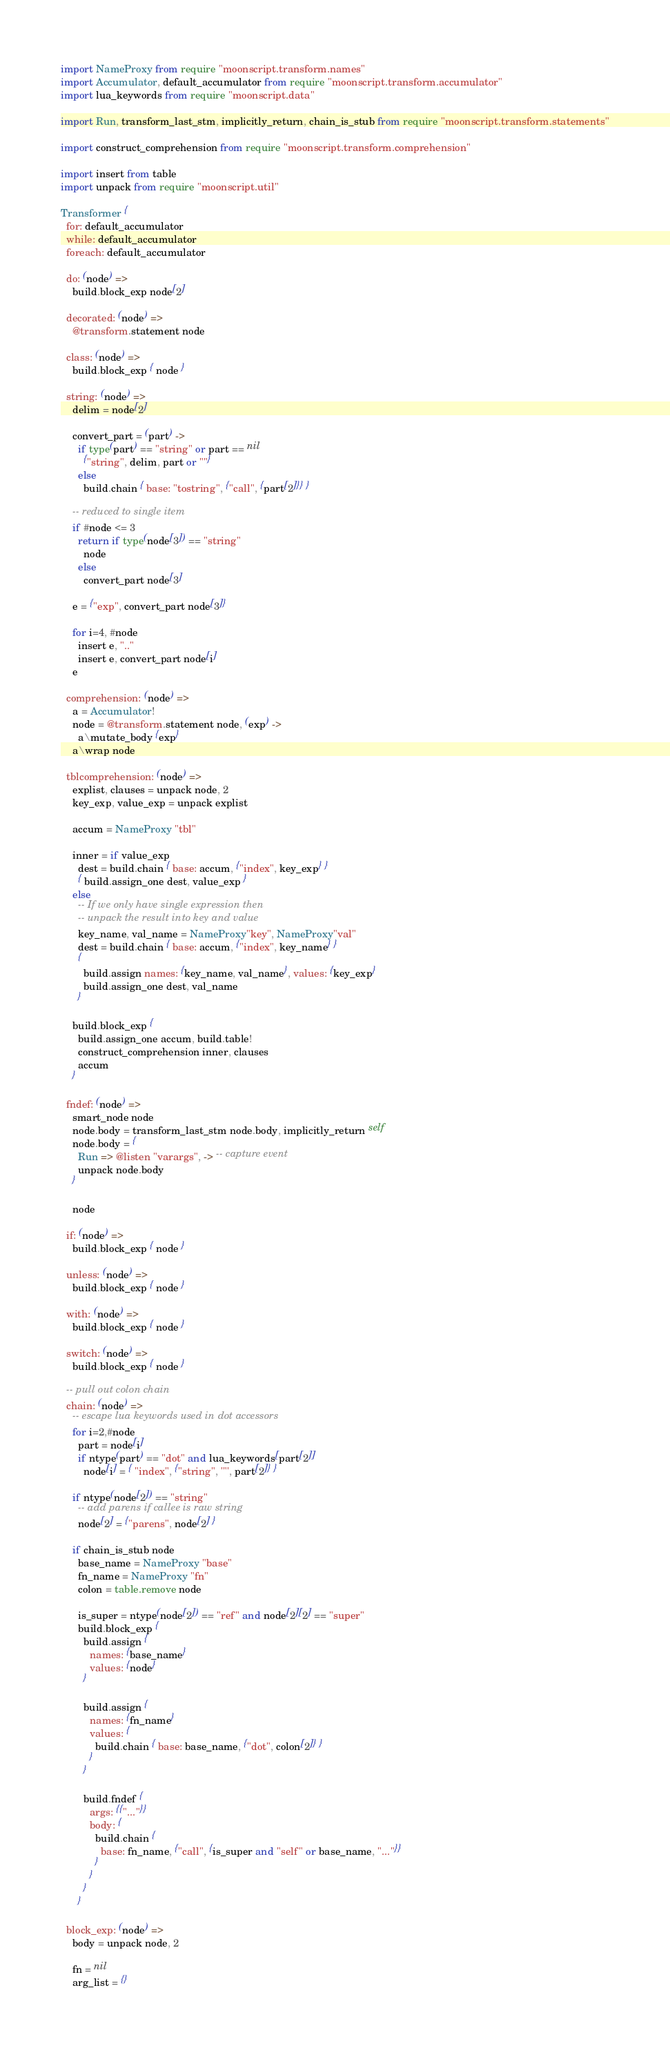<code> <loc_0><loc_0><loc_500><loc_500><_MoonScript_>import NameProxy from require "moonscript.transform.names"
import Accumulator, default_accumulator from require "moonscript.transform.accumulator"
import lua_keywords from require "moonscript.data"

import Run, transform_last_stm, implicitly_return, chain_is_stub from require "moonscript.transform.statements"

import construct_comprehension from require "moonscript.transform.comprehension"

import insert from table
import unpack from require "moonscript.util"

Transformer {
  for: default_accumulator
  while: default_accumulator
  foreach: default_accumulator

  do: (node) =>
    build.block_exp node[2]

  decorated: (node) =>
    @transform.statement node

  class: (node) =>
    build.block_exp { node }

  string: (node) =>
    delim = node[2]

    convert_part = (part) ->
      if type(part) == "string" or part == nil
        {"string", delim, part or ""}
      else
        build.chain { base: "tostring", {"call", {part[2]}} }

    -- reduced to single item
    if #node <= 3
      return if type(node[3]) == "string"
        node
      else
        convert_part node[3]

    e = {"exp", convert_part node[3]}

    for i=4, #node
      insert e, ".."
      insert e, convert_part node[i]
    e

  comprehension: (node) =>
    a = Accumulator!
    node = @transform.statement node, (exp) ->
      a\mutate_body {exp}
    a\wrap node

  tblcomprehension: (node) =>
    explist, clauses = unpack node, 2
    key_exp, value_exp = unpack explist

    accum = NameProxy "tbl"

    inner = if value_exp
      dest = build.chain { base: accum, {"index", key_exp} }
      { build.assign_one dest, value_exp }
    else
      -- If we only have single expression then
      -- unpack the result into key and value
      key_name, val_name = NameProxy"key", NameProxy"val"
      dest = build.chain { base: accum, {"index", key_name} }
      {
        build.assign names: {key_name, val_name}, values: {key_exp}
        build.assign_one dest, val_name
      }

    build.block_exp {
      build.assign_one accum, build.table!
      construct_comprehension inner, clauses
      accum
    }

  fndef: (node) =>
    smart_node node
    node.body = transform_last_stm node.body, implicitly_return self
    node.body = {
      Run => @listen "varargs", -> -- capture event
      unpack node.body
    }

    node

  if: (node) =>
    build.block_exp { node }

  unless: (node) =>
    build.block_exp { node }

  with: (node) =>
    build.block_exp { node }

  switch: (node) =>
    build.block_exp { node }

  -- pull out colon chain
  chain: (node) =>
    -- escape lua keywords used in dot accessors
    for i=2,#node
      part = node[i]
      if ntype(part) == "dot" and lua_keywords[part[2]]
        node[i] = { "index", {"string", '"', part[2]} }

    if ntype(node[2]) == "string"
      -- add parens if callee is raw string
      node[2] = {"parens", node[2] }

    if chain_is_stub node
      base_name = NameProxy "base"
      fn_name = NameProxy "fn"
      colon = table.remove node

      is_super = ntype(node[2]) == "ref" and node[2][2] == "super"
      build.block_exp {
        build.assign {
          names: {base_name}
          values: {node}
        }

        build.assign {
          names: {fn_name}
          values: {
            build.chain { base: base_name, {"dot", colon[2]} }
          }
        }

        build.fndef {
          args: {{"..."}}
          body: {
            build.chain {
              base: fn_name, {"call", {is_super and "self" or base_name, "..."}}
            }
          }
        }
      }

  block_exp: (node) =>
    body = unpack node, 2

    fn = nil
    arg_list = {}
</code> 